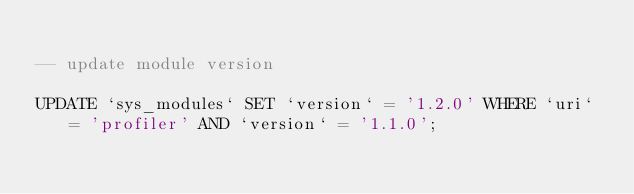Convert code to text. <code><loc_0><loc_0><loc_500><loc_500><_SQL_>
-- update module version

UPDATE `sys_modules` SET `version` = '1.2.0' WHERE `uri` = 'profiler' AND `version` = '1.1.0';
</code> 